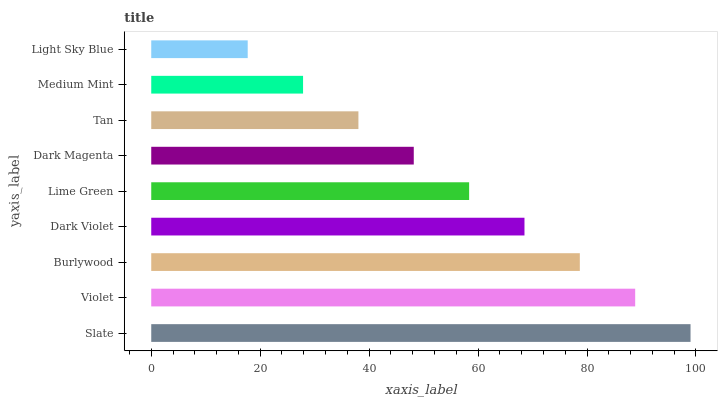Is Light Sky Blue the minimum?
Answer yes or no. Yes. Is Slate the maximum?
Answer yes or no. Yes. Is Violet the minimum?
Answer yes or no. No. Is Violet the maximum?
Answer yes or no. No. Is Slate greater than Violet?
Answer yes or no. Yes. Is Violet less than Slate?
Answer yes or no. Yes. Is Violet greater than Slate?
Answer yes or no. No. Is Slate less than Violet?
Answer yes or no. No. Is Lime Green the high median?
Answer yes or no. Yes. Is Lime Green the low median?
Answer yes or no. Yes. Is Light Sky Blue the high median?
Answer yes or no. No. Is Dark Violet the low median?
Answer yes or no. No. 